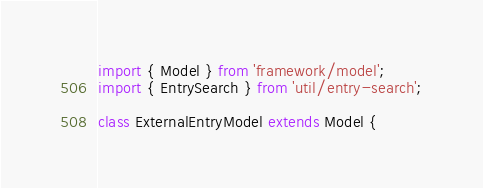Convert code to text. <code><loc_0><loc_0><loc_500><loc_500><_JavaScript_>import { Model } from 'framework/model';
import { EntrySearch } from 'util/entry-search';

class ExternalEntryModel extends Model {</code> 